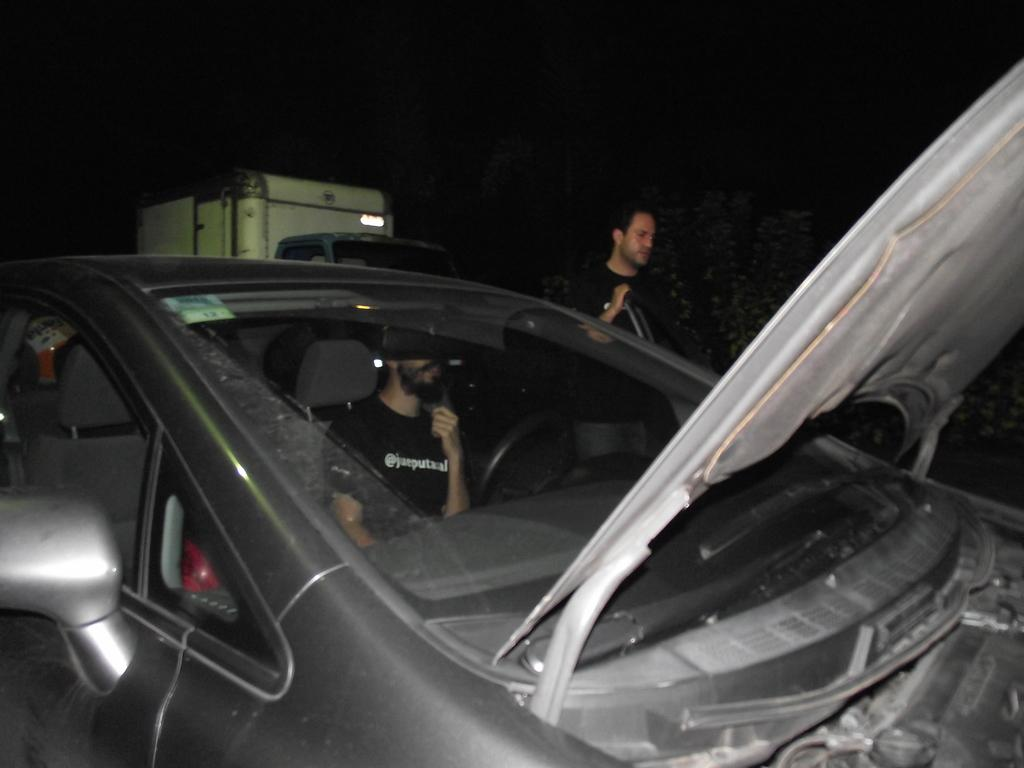What is the main subject of the image? The main subject of the image is a car. What is happening with the car in the image? There is a man sitting in the car and another man standing near the car. What type of tomatoes are being used as a representative for the parent in the image? There are no tomatoes or any representation of a parent present in the image. 